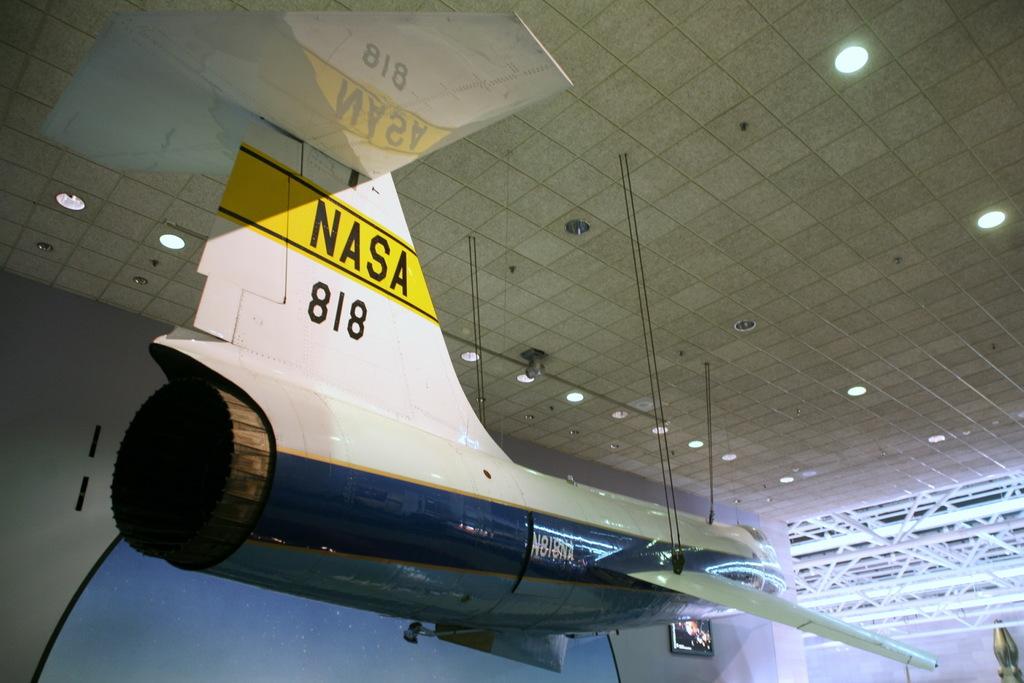What are the numbers on that space craft?
Your response must be concise. 818. What organization made this plane?
Your response must be concise. Nasa. 